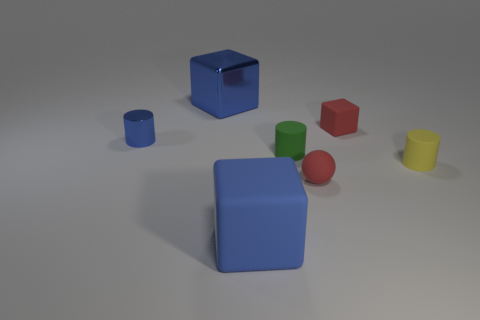Subtract all yellow cylinders. How many cylinders are left? 2 Subtract all matte blocks. How many blocks are left? 1 Add 2 tiny yellow rubber cylinders. How many objects exist? 9 Subtract 0 gray spheres. How many objects are left? 7 Subtract all cylinders. How many objects are left? 4 Subtract 1 balls. How many balls are left? 0 Subtract all red blocks. Subtract all red cylinders. How many blocks are left? 2 Subtract all gray cylinders. How many yellow cubes are left? 0 Subtract all purple shiny things. Subtract all small blue things. How many objects are left? 6 Add 2 blue things. How many blue things are left? 5 